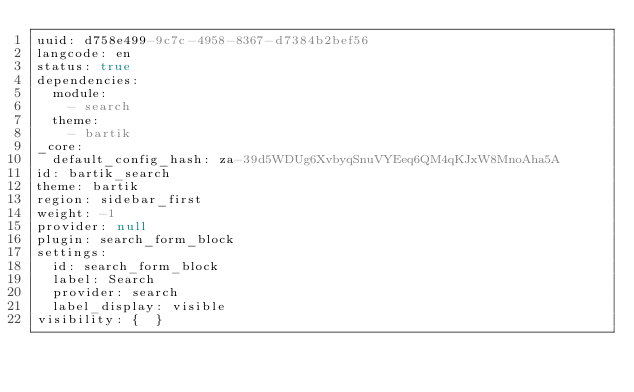Convert code to text. <code><loc_0><loc_0><loc_500><loc_500><_YAML_>uuid: d758e499-9c7c-4958-8367-d7384b2bef56
langcode: en
status: true
dependencies:
  module:
    - search
  theme:
    - bartik
_core:
  default_config_hash: za-39d5WDUg6XvbyqSnuVYEeq6QM4qKJxW8MnoAha5A
id: bartik_search
theme: bartik
region: sidebar_first
weight: -1
provider: null
plugin: search_form_block
settings:
  id: search_form_block
  label: Search
  provider: search
  label_display: visible
visibility: {  }
</code> 